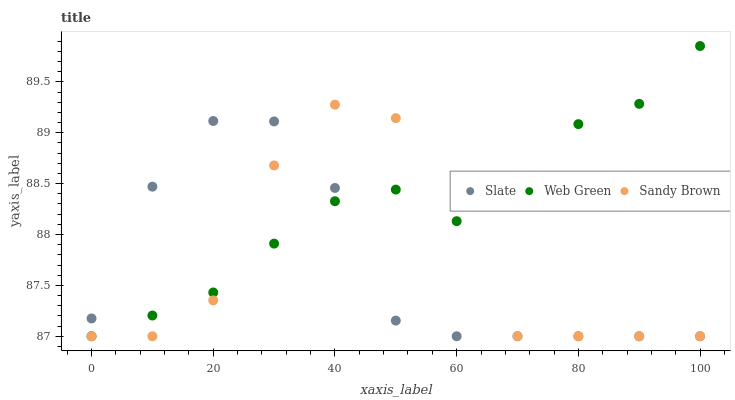Does Slate have the minimum area under the curve?
Answer yes or no. Yes. Does Web Green have the maximum area under the curve?
Answer yes or no. Yes. Does Sandy Brown have the minimum area under the curve?
Answer yes or no. No. Does Sandy Brown have the maximum area under the curve?
Answer yes or no. No. Is Web Green the smoothest?
Answer yes or no. Yes. Is Sandy Brown the roughest?
Answer yes or no. Yes. Is Sandy Brown the smoothest?
Answer yes or no. No. Is Web Green the roughest?
Answer yes or no. No. Does Slate have the lowest value?
Answer yes or no. Yes. Does Web Green have the highest value?
Answer yes or no. Yes. Does Sandy Brown have the highest value?
Answer yes or no. No. Does Sandy Brown intersect Web Green?
Answer yes or no. Yes. Is Sandy Brown less than Web Green?
Answer yes or no. No. Is Sandy Brown greater than Web Green?
Answer yes or no. No. 